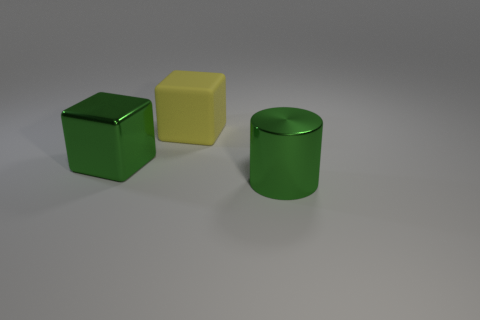There is a big shiny object that is the same color as the cylinder; what shape is it?
Give a very brief answer. Cube. Do the large metal object that is behind the green metal cylinder and the thing that is behind the green cube have the same shape?
Offer a terse response. Yes. There is a object that is on the left side of the green shiny cylinder and in front of the yellow thing; how big is it?
Your answer should be very brief. Large. There is a metal object that is the same shape as the yellow matte object; what color is it?
Ensure brevity in your answer.  Green. There is a shiny object behind the cylinder that is in front of the big yellow matte thing; what color is it?
Provide a short and direct response. Green. The big yellow thing has what shape?
Offer a very short reply. Cube. There is a object that is both to the right of the green block and in front of the large yellow object; what shape is it?
Keep it short and to the point. Cylinder. What color is the big block that is the same material as the big green cylinder?
Keep it short and to the point. Green. What shape is the large green thing that is right of the big shiny thing behind the metal object that is to the right of the green shiny block?
Your answer should be compact. Cylinder. The cylinder has what size?
Provide a succinct answer. Large. 